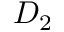Convert formula to latex. <formula><loc_0><loc_0><loc_500><loc_500>D _ { 2 }</formula> 